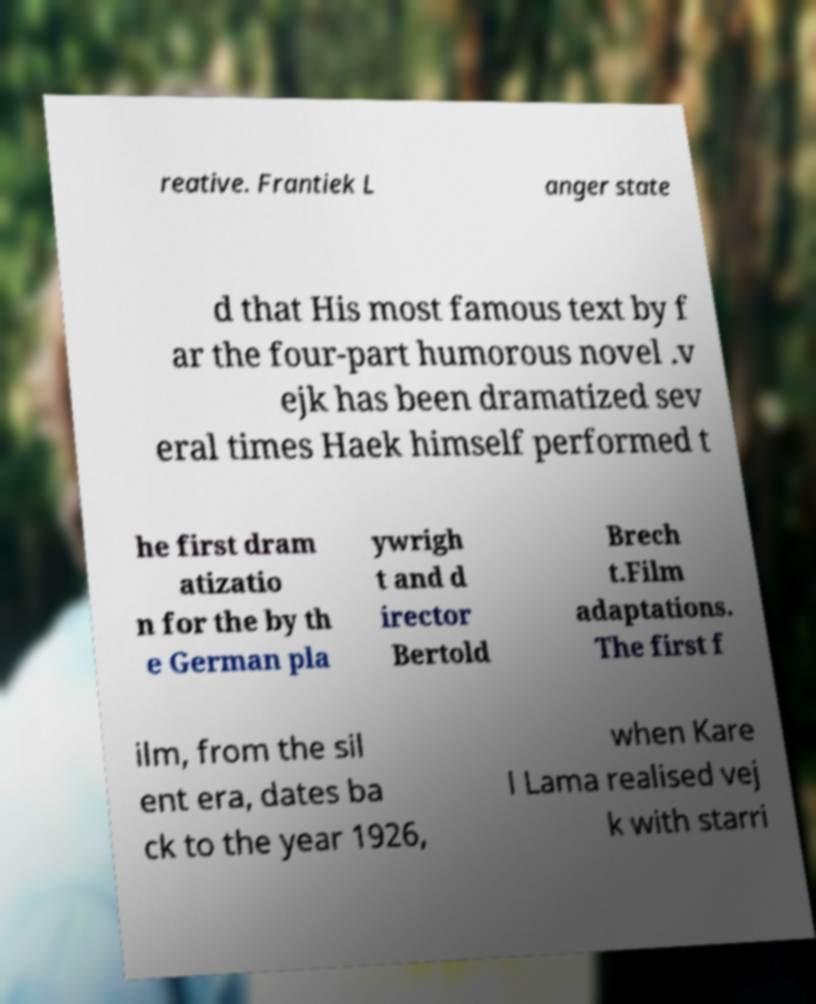Please read and relay the text visible in this image. What does it say? reative. Frantiek L anger state d that His most famous text by f ar the four-part humorous novel .v ejk has been dramatized sev eral times Haek himself performed t he first dram atizatio n for the by th e German pla ywrigh t and d irector Bertold Brech t.Film adaptations. The first f ilm, from the sil ent era, dates ba ck to the year 1926, when Kare l Lama realised vej k with starri 